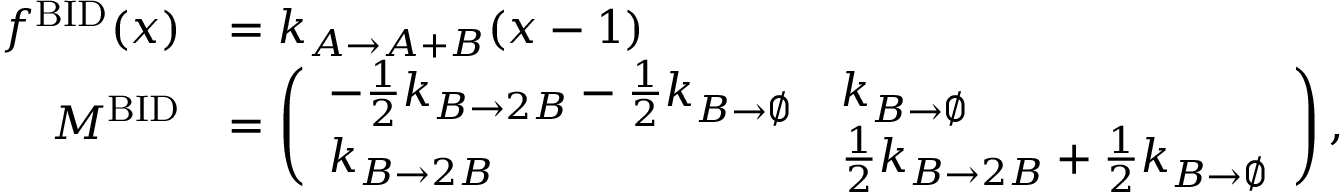<formula> <loc_0><loc_0><loc_500><loc_500>\begin{array} { r l } { f ^ { B I D } ( x ) } & { = k _ { A \to A + B } ( x - 1 ) } \\ { M ^ { B I D } } & { = \left ( \begin{array} { l l } { - \frac { 1 } { 2 } k _ { B \to 2 B } - \frac { 1 } { 2 } k _ { B \to \emptyset } } & { k _ { B \to \emptyset } } \\ { k _ { B \to 2 B } } & { \frac { 1 } { 2 } k _ { B \to 2 B } + \frac { 1 } { 2 } k _ { B \to \emptyset } } \end{array} \right ) , } \end{array}</formula> 